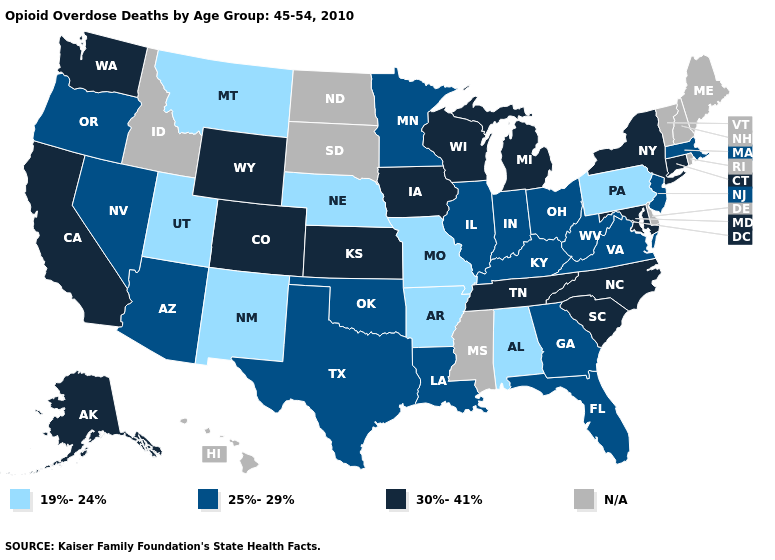Does the map have missing data?
Be succinct. Yes. Which states hav the highest value in the South?
Write a very short answer. Maryland, North Carolina, South Carolina, Tennessee. What is the value of Utah?
Answer briefly. 19%-24%. What is the value of New Mexico?
Give a very brief answer. 19%-24%. Name the states that have a value in the range 30%-41%?
Write a very short answer. Alaska, California, Colorado, Connecticut, Iowa, Kansas, Maryland, Michigan, New York, North Carolina, South Carolina, Tennessee, Washington, Wisconsin, Wyoming. What is the lowest value in states that border West Virginia?
Write a very short answer. 19%-24%. What is the lowest value in the South?
Concise answer only. 19%-24%. What is the lowest value in the USA?
Be succinct. 19%-24%. What is the highest value in the USA?
Keep it brief. 30%-41%. What is the value of Nebraska?
Concise answer only. 19%-24%. Name the states that have a value in the range 30%-41%?
Be succinct. Alaska, California, Colorado, Connecticut, Iowa, Kansas, Maryland, Michigan, New York, North Carolina, South Carolina, Tennessee, Washington, Wisconsin, Wyoming. Among the states that border Oregon , does California have the lowest value?
Write a very short answer. No. Name the states that have a value in the range 19%-24%?
Short answer required. Alabama, Arkansas, Missouri, Montana, Nebraska, New Mexico, Pennsylvania, Utah. Name the states that have a value in the range 30%-41%?
Be succinct. Alaska, California, Colorado, Connecticut, Iowa, Kansas, Maryland, Michigan, New York, North Carolina, South Carolina, Tennessee, Washington, Wisconsin, Wyoming. Which states have the lowest value in the MidWest?
Answer briefly. Missouri, Nebraska. 